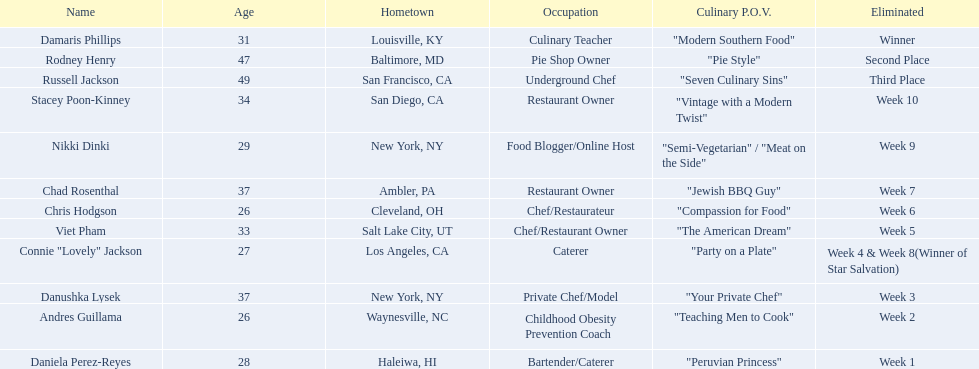Who are the participants? Damaris Phillips, 31, Rodney Henry, 47, Russell Jackson, 49, Stacey Poon-Kinney, 34, Nikki Dinki, 29, Chad Rosenthal, 37, Chris Hodgson, 26, Viet Pham, 33, Connie "Lovely" Jackson, 27, Danushka Lysek, 37, Andres Guillama, 26, Daniela Perez-Reyes, 28. What is chris hodgson's age? 26. Is there another competitor with the same age? Andres Guillama. 